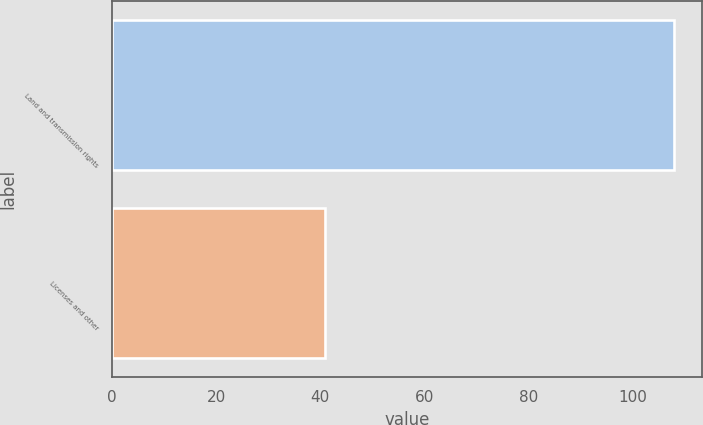<chart> <loc_0><loc_0><loc_500><loc_500><bar_chart><fcel>Land and transmission rights<fcel>Licenses and other<nl><fcel>108<fcel>41<nl></chart> 